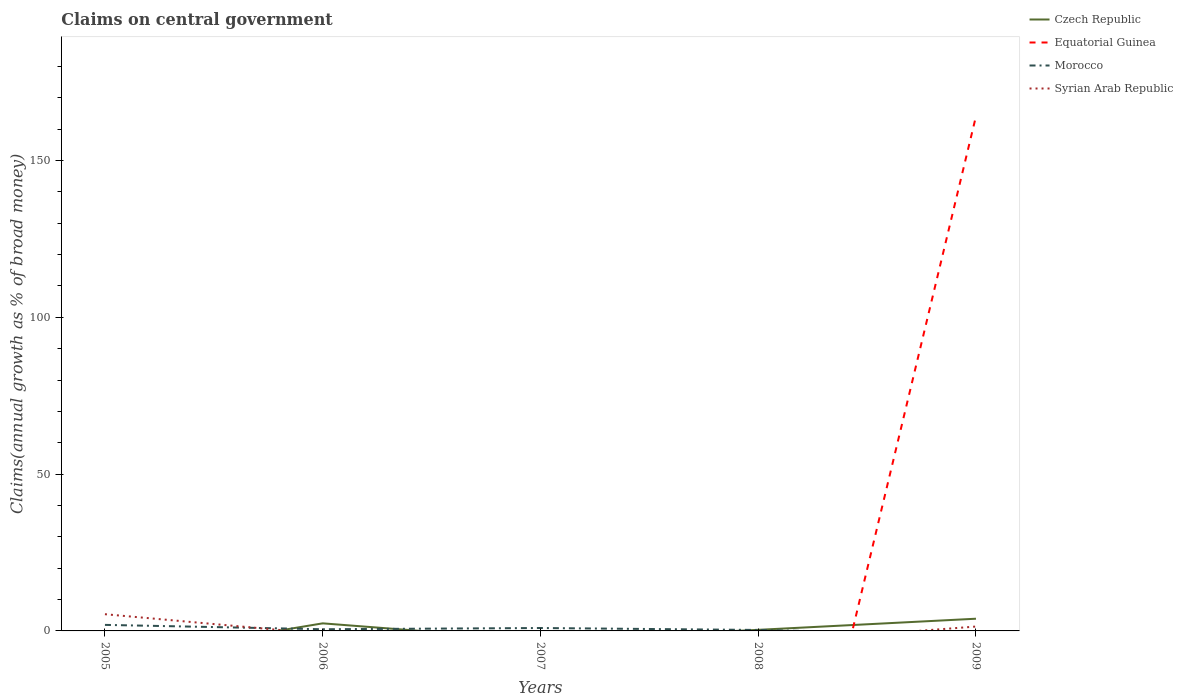How many different coloured lines are there?
Give a very brief answer. 4. Does the line corresponding to Morocco intersect with the line corresponding to Syrian Arab Republic?
Ensure brevity in your answer.  Yes. Across all years, what is the maximum percentage of broad money claimed on centeral government in Morocco?
Give a very brief answer. 0. What is the total percentage of broad money claimed on centeral government in Morocco in the graph?
Offer a very short reply. 0.23. What is the difference between the highest and the second highest percentage of broad money claimed on centeral government in Syrian Arab Republic?
Offer a very short reply. 5.33. What is the difference between the highest and the lowest percentage of broad money claimed on centeral government in Equatorial Guinea?
Provide a short and direct response. 1. Is the percentage of broad money claimed on centeral government in Syrian Arab Republic strictly greater than the percentage of broad money claimed on centeral government in Czech Republic over the years?
Give a very brief answer. No. How many lines are there?
Offer a very short reply. 4. How many years are there in the graph?
Provide a succinct answer. 5. What is the difference between two consecutive major ticks on the Y-axis?
Your answer should be very brief. 50. Does the graph contain any zero values?
Provide a succinct answer. Yes. Does the graph contain grids?
Keep it short and to the point. No. Where does the legend appear in the graph?
Give a very brief answer. Top right. How many legend labels are there?
Your answer should be very brief. 4. What is the title of the graph?
Your response must be concise. Claims on central government. Does "Paraguay" appear as one of the legend labels in the graph?
Your answer should be compact. No. What is the label or title of the X-axis?
Your answer should be very brief. Years. What is the label or title of the Y-axis?
Your response must be concise. Claims(annual growth as % of broad money). What is the Claims(annual growth as % of broad money) in Czech Republic in 2005?
Offer a terse response. 0. What is the Claims(annual growth as % of broad money) in Morocco in 2005?
Give a very brief answer. 1.92. What is the Claims(annual growth as % of broad money) of Syrian Arab Republic in 2005?
Ensure brevity in your answer.  5.33. What is the Claims(annual growth as % of broad money) in Czech Republic in 2006?
Your answer should be very brief. 2.42. What is the Claims(annual growth as % of broad money) in Morocco in 2006?
Ensure brevity in your answer.  0.53. What is the Claims(annual growth as % of broad money) in Syrian Arab Republic in 2006?
Provide a succinct answer. 0. What is the Claims(annual growth as % of broad money) in Morocco in 2007?
Make the answer very short. 0.93. What is the Claims(annual growth as % of broad money) of Syrian Arab Republic in 2007?
Offer a very short reply. 0. What is the Claims(annual growth as % of broad money) in Czech Republic in 2008?
Provide a succinct answer. 0.34. What is the Claims(annual growth as % of broad money) in Morocco in 2008?
Ensure brevity in your answer.  0.31. What is the Claims(annual growth as % of broad money) of Syrian Arab Republic in 2008?
Your answer should be very brief. 0. What is the Claims(annual growth as % of broad money) of Czech Republic in 2009?
Keep it short and to the point. 3.89. What is the Claims(annual growth as % of broad money) of Equatorial Guinea in 2009?
Your answer should be compact. 164.13. What is the Claims(annual growth as % of broad money) in Morocco in 2009?
Offer a very short reply. 0. What is the Claims(annual growth as % of broad money) of Syrian Arab Republic in 2009?
Ensure brevity in your answer.  1.39. Across all years, what is the maximum Claims(annual growth as % of broad money) in Czech Republic?
Your response must be concise. 3.89. Across all years, what is the maximum Claims(annual growth as % of broad money) in Equatorial Guinea?
Offer a terse response. 164.13. Across all years, what is the maximum Claims(annual growth as % of broad money) in Morocco?
Keep it short and to the point. 1.92. Across all years, what is the maximum Claims(annual growth as % of broad money) of Syrian Arab Republic?
Offer a very short reply. 5.33. Across all years, what is the minimum Claims(annual growth as % of broad money) in Czech Republic?
Make the answer very short. 0. Across all years, what is the minimum Claims(annual growth as % of broad money) in Syrian Arab Republic?
Your answer should be compact. 0. What is the total Claims(annual growth as % of broad money) in Czech Republic in the graph?
Provide a short and direct response. 6.65. What is the total Claims(annual growth as % of broad money) of Equatorial Guinea in the graph?
Your answer should be compact. 164.13. What is the total Claims(annual growth as % of broad money) in Morocco in the graph?
Offer a terse response. 3.69. What is the total Claims(annual growth as % of broad money) in Syrian Arab Republic in the graph?
Your answer should be very brief. 6.72. What is the difference between the Claims(annual growth as % of broad money) of Morocco in 2005 and that in 2006?
Provide a succinct answer. 1.39. What is the difference between the Claims(annual growth as % of broad money) in Morocco in 2005 and that in 2008?
Offer a terse response. 1.62. What is the difference between the Claims(annual growth as % of broad money) in Syrian Arab Republic in 2005 and that in 2009?
Offer a terse response. 3.94. What is the difference between the Claims(annual growth as % of broad money) of Morocco in 2006 and that in 2007?
Provide a short and direct response. -0.39. What is the difference between the Claims(annual growth as % of broad money) of Czech Republic in 2006 and that in 2008?
Make the answer very short. 2.07. What is the difference between the Claims(annual growth as % of broad money) in Morocco in 2006 and that in 2008?
Ensure brevity in your answer.  0.23. What is the difference between the Claims(annual growth as % of broad money) in Czech Republic in 2006 and that in 2009?
Your response must be concise. -1.48. What is the difference between the Claims(annual growth as % of broad money) in Morocco in 2007 and that in 2008?
Give a very brief answer. 0.62. What is the difference between the Claims(annual growth as % of broad money) in Czech Republic in 2008 and that in 2009?
Offer a very short reply. -3.55. What is the difference between the Claims(annual growth as % of broad money) of Morocco in 2005 and the Claims(annual growth as % of broad money) of Syrian Arab Republic in 2009?
Provide a succinct answer. 0.53. What is the difference between the Claims(annual growth as % of broad money) of Czech Republic in 2006 and the Claims(annual growth as % of broad money) of Morocco in 2007?
Offer a terse response. 1.49. What is the difference between the Claims(annual growth as % of broad money) of Czech Republic in 2006 and the Claims(annual growth as % of broad money) of Morocco in 2008?
Provide a succinct answer. 2.11. What is the difference between the Claims(annual growth as % of broad money) of Czech Republic in 2006 and the Claims(annual growth as % of broad money) of Equatorial Guinea in 2009?
Keep it short and to the point. -161.71. What is the difference between the Claims(annual growth as % of broad money) of Czech Republic in 2006 and the Claims(annual growth as % of broad money) of Syrian Arab Republic in 2009?
Keep it short and to the point. 1.02. What is the difference between the Claims(annual growth as % of broad money) of Morocco in 2006 and the Claims(annual growth as % of broad money) of Syrian Arab Republic in 2009?
Offer a terse response. -0.86. What is the difference between the Claims(annual growth as % of broad money) of Morocco in 2007 and the Claims(annual growth as % of broad money) of Syrian Arab Republic in 2009?
Offer a terse response. -0.47. What is the difference between the Claims(annual growth as % of broad money) in Czech Republic in 2008 and the Claims(annual growth as % of broad money) in Equatorial Guinea in 2009?
Your answer should be very brief. -163.78. What is the difference between the Claims(annual growth as % of broad money) in Czech Republic in 2008 and the Claims(annual growth as % of broad money) in Syrian Arab Republic in 2009?
Provide a succinct answer. -1.05. What is the difference between the Claims(annual growth as % of broad money) of Morocco in 2008 and the Claims(annual growth as % of broad money) of Syrian Arab Republic in 2009?
Offer a terse response. -1.09. What is the average Claims(annual growth as % of broad money) in Czech Republic per year?
Your response must be concise. 1.33. What is the average Claims(annual growth as % of broad money) of Equatorial Guinea per year?
Offer a very short reply. 32.83. What is the average Claims(annual growth as % of broad money) in Morocco per year?
Your answer should be very brief. 0.74. What is the average Claims(annual growth as % of broad money) in Syrian Arab Republic per year?
Your answer should be compact. 1.34. In the year 2005, what is the difference between the Claims(annual growth as % of broad money) in Morocco and Claims(annual growth as % of broad money) in Syrian Arab Republic?
Offer a very short reply. -3.41. In the year 2006, what is the difference between the Claims(annual growth as % of broad money) of Czech Republic and Claims(annual growth as % of broad money) of Morocco?
Make the answer very short. 1.88. In the year 2008, what is the difference between the Claims(annual growth as % of broad money) of Czech Republic and Claims(annual growth as % of broad money) of Morocco?
Your answer should be very brief. 0.04. In the year 2009, what is the difference between the Claims(annual growth as % of broad money) of Czech Republic and Claims(annual growth as % of broad money) of Equatorial Guinea?
Ensure brevity in your answer.  -160.24. In the year 2009, what is the difference between the Claims(annual growth as % of broad money) in Czech Republic and Claims(annual growth as % of broad money) in Syrian Arab Republic?
Make the answer very short. 2.5. In the year 2009, what is the difference between the Claims(annual growth as % of broad money) of Equatorial Guinea and Claims(annual growth as % of broad money) of Syrian Arab Republic?
Offer a terse response. 162.73. What is the ratio of the Claims(annual growth as % of broad money) of Morocco in 2005 to that in 2006?
Make the answer very short. 3.61. What is the ratio of the Claims(annual growth as % of broad money) of Morocco in 2005 to that in 2007?
Ensure brevity in your answer.  2.08. What is the ratio of the Claims(annual growth as % of broad money) of Morocco in 2005 to that in 2008?
Provide a short and direct response. 6.29. What is the ratio of the Claims(annual growth as % of broad money) in Syrian Arab Republic in 2005 to that in 2009?
Ensure brevity in your answer.  3.83. What is the ratio of the Claims(annual growth as % of broad money) in Morocco in 2006 to that in 2007?
Give a very brief answer. 0.58. What is the ratio of the Claims(annual growth as % of broad money) of Czech Republic in 2006 to that in 2008?
Provide a short and direct response. 7.02. What is the ratio of the Claims(annual growth as % of broad money) of Morocco in 2006 to that in 2008?
Give a very brief answer. 1.74. What is the ratio of the Claims(annual growth as % of broad money) of Czech Republic in 2006 to that in 2009?
Your answer should be compact. 0.62. What is the ratio of the Claims(annual growth as % of broad money) of Morocco in 2007 to that in 2008?
Keep it short and to the point. 3.03. What is the ratio of the Claims(annual growth as % of broad money) in Czech Republic in 2008 to that in 2009?
Keep it short and to the point. 0.09. What is the difference between the highest and the second highest Claims(annual growth as % of broad money) in Czech Republic?
Give a very brief answer. 1.48. What is the difference between the highest and the lowest Claims(annual growth as % of broad money) of Czech Republic?
Keep it short and to the point. 3.89. What is the difference between the highest and the lowest Claims(annual growth as % of broad money) in Equatorial Guinea?
Your response must be concise. 164.13. What is the difference between the highest and the lowest Claims(annual growth as % of broad money) in Morocco?
Your response must be concise. 1.92. What is the difference between the highest and the lowest Claims(annual growth as % of broad money) in Syrian Arab Republic?
Provide a succinct answer. 5.33. 